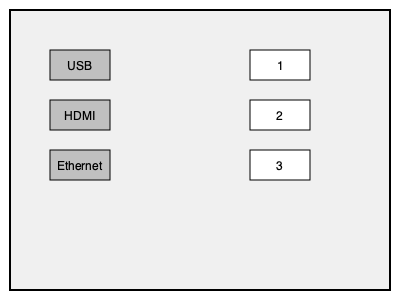Match the appropriate cable connectors (1, 2, 3) to their corresponding ports (USB, HDMI, Ethernet) in the computer setup shown above. To match the cable connectors to their corresponding ports, follow these steps:

1. Identify the ports:
   - The top port is labeled USB
   - The middle port is labeled HDMI
   - The bottom port is labeled Ethernet

2. Analyze the connectors:
   - Connector 1 is rectangular and relatively small, typical of a USB connector
   - Connector 2 is wider and flatter, characteristic of an HDMI connector
   - Connector 3 is square-shaped with a clip, typical of an Ethernet (RJ45) connector

3. Match the connectors to the ports:
   - USB port matches with connector 1
   - HDMI port matches with connector 2
   - Ethernet port matches with connector 3

4. Create the final pairing:
   - USB - 1
   - HDMI - 2
   - Ethernet - 3
Answer: USB-1, HDMI-2, Ethernet-3 